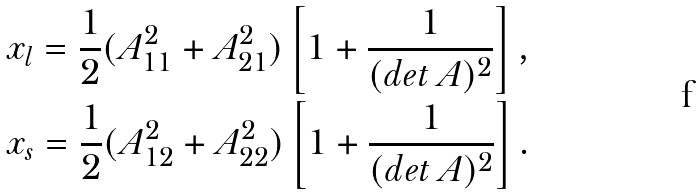Convert formula to latex. <formula><loc_0><loc_0><loc_500><loc_500>& x _ { l } = \frac { 1 } { 2 } ( A _ { 1 1 } ^ { 2 } + A _ { 2 1 } ^ { 2 } ) \left [ 1 + \frac { 1 } { ( d e t \, A ) ^ { 2 } } \right ] , \\ & x _ { s } = \frac { 1 } { 2 } ( A _ { 1 2 } ^ { 2 } + A _ { 2 2 } ^ { 2 } ) \left [ 1 + \frac { 1 } { ( d e t \, A ) ^ { 2 } } \right ] .</formula> 